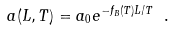<formula> <loc_0><loc_0><loc_500><loc_500>a ( L , T ) = a _ { 0 } e ^ { - f _ { B } ( T ) L / T } \ .</formula> 